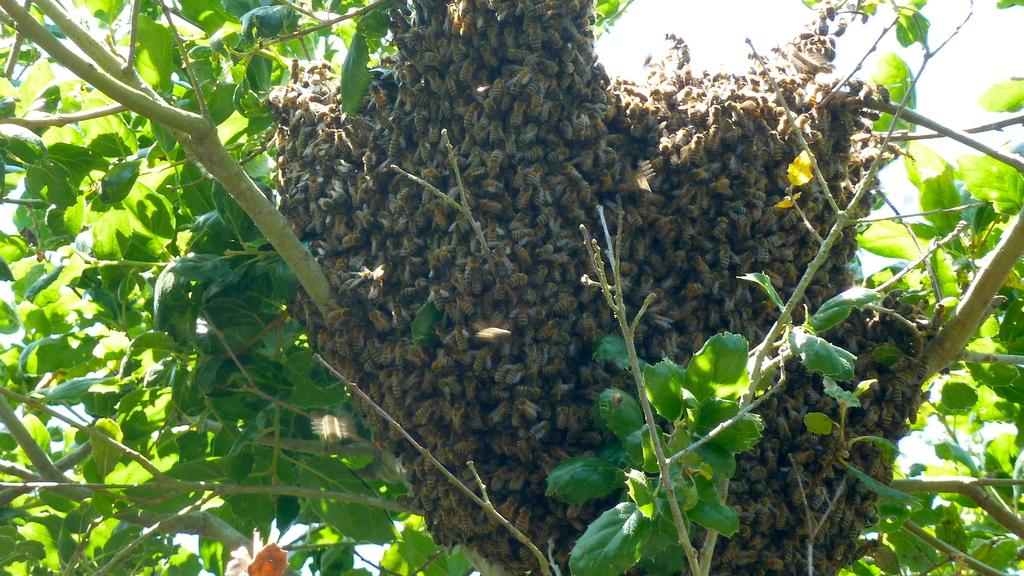What type of insects are present in the image? There are honey bees in the image. What are the honey bees doing in the image? The honey bees are on a comb. Where is the comb located in the image? The comb is on a tree. What is visible at the top of the image? The sky is visible at the top of the image. How many dimes can be seen on the tree in the image? There are no dimes present in the image; it features honey bees on a comb on a tree. Is there any evidence of a crime being committed in the image? There is no indication of a crime being committed in the image; it shows honey bees on a comb on a tree. 